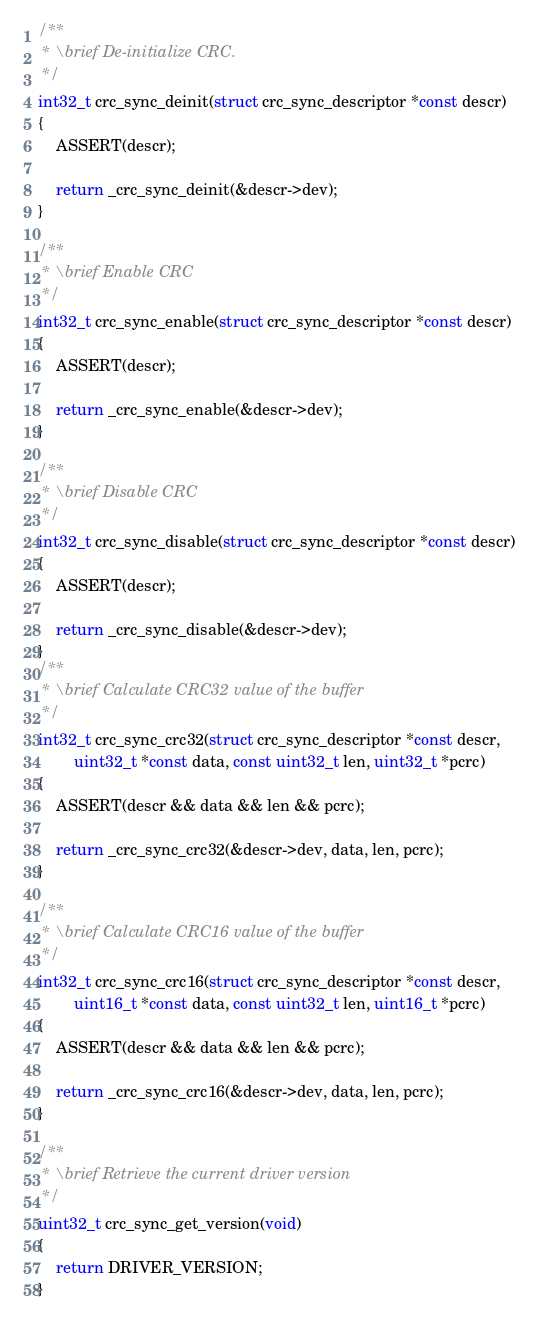Convert code to text. <code><loc_0><loc_0><loc_500><loc_500><_C_>/**
 * \brief De-initialize CRC.
 */
int32_t crc_sync_deinit(struct crc_sync_descriptor *const descr)
{
	ASSERT(descr);

	return _crc_sync_deinit(&descr->dev);
}

/**
 * \brief Enable CRC
 */
int32_t crc_sync_enable(struct crc_sync_descriptor *const descr)
{
	ASSERT(descr);

	return _crc_sync_enable(&descr->dev);
}

/**
 * \brief Disable CRC
 */
int32_t crc_sync_disable(struct crc_sync_descriptor *const descr)
{
	ASSERT(descr);

	return _crc_sync_disable(&descr->dev);
}
/**
 * \brief Calculate CRC32 value of the buffer
 */
int32_t crc_sync_crc32(struct crc_sync_descriptor *const descr,
		uint32_t *const data, const uint32_t len, uint32_t *pcrc)
{
	ASSERT(descr && data && len && pcrc);

	return _crc_sync_crc32(&descr->dev, data, len, pcrc);
}

/**
 * \brief Calculate CRC16 value of the buffer
 */
int32_t crc_sync_crc16(struct crc_sync_descriptor *const descr,
		uint16_t *const data, const uint32_t len, uint16_t *pcrc)
{
	ASSERT(descr && data && len && pcrc);

	return _crc_sync_crc16(&descr->dev, data, len, pcrc);
}

/**
 * \brief Retrieve the current driver version
 */
uint32_t crc_sync_get_version(void)
{
	return DRIVER_VERSION;
}
</code> 